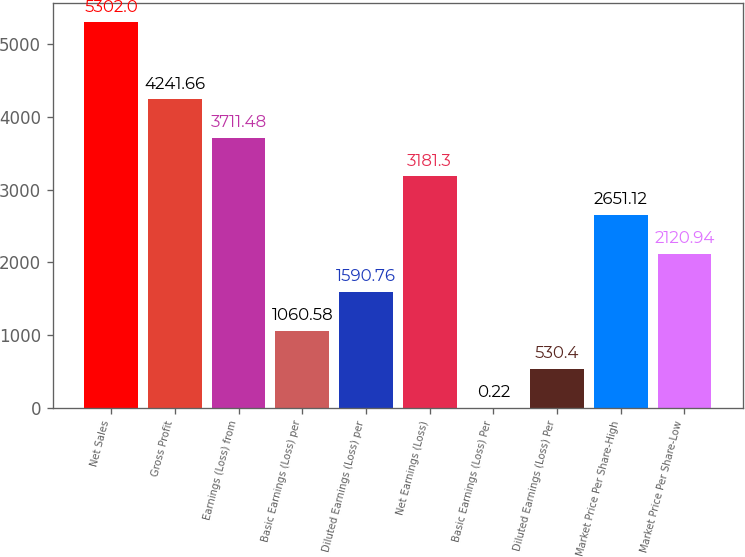Convert chart. <chart><loc_0><loc_0><loc_500><loc_500><bar_chart><fcel>Net Sales<fcel>Gross Profit<fcel>Earnings (Loss) from<fcel>Basic Earnings (Loss) per<fcel>Diluted Earnings (Loss) per<fcel>Net Earnings (Loss)<fcel>Basic Earnings (Loss) Per<fcel>Diluted Earnings (Loss) Per<fcel>Market Price Per Share-High<fcel>Market Price Per Share-Low<nl><fcel>5302<fcel>4241.66<fcel>3711.48<fcel>1060.58<fcel>1590.76<fcel>3181.3<fcel>0.22<fcel>530.4<fcel>2651.12<fcel>2120.94<nl></chart> 